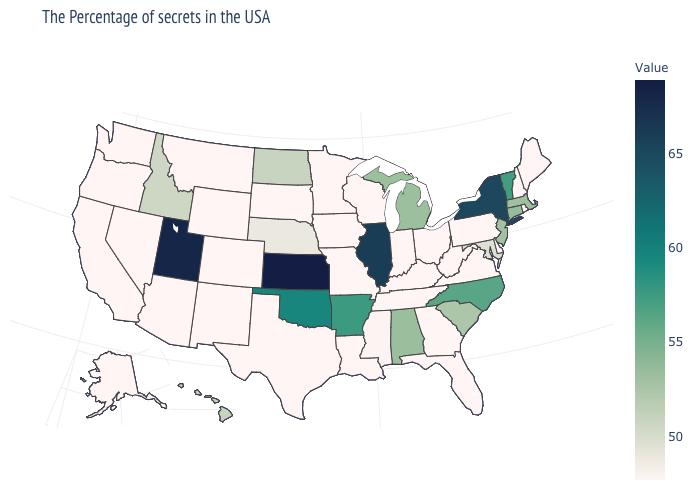Which states have the lowest value in the USA?
Short answer required. Maine, Rhode Island, New Hampshire, Delaware, Pennsylvania, Virginia, West Virginia, Ohio, Florida, Georgia, Kentucky, Indiana, Tennessee, Wisconsin, Louisiana, Missouri, Minnesota, Iowa, Texas, South Dakota, Wyoming, Colorado, New Mexico, Montana, Arizona, Nevada, California, Washington, Oregon, Alaska. Which states have the lowest value in the Northeast?
Short answer required. Maine, Rhode Island, New Hampshire, Pennsylvania. 